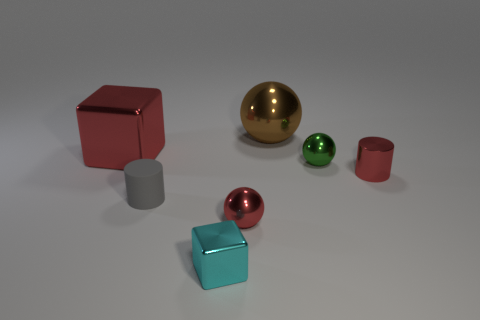Add 2 big red cubes. How many objects exist? 9 Subtract all blocks. How many objects are left? 5 Add 4 tiny things. How many tiny things exist? 9 Subtract 0 yellow cubes. How many objects are left? 7 Subtract all tiny green metallic things. Subtract all large metallic things. How many objects are left? 4 Add 7 red metallic cylinders. How many red metallic cylinders are left? 8 